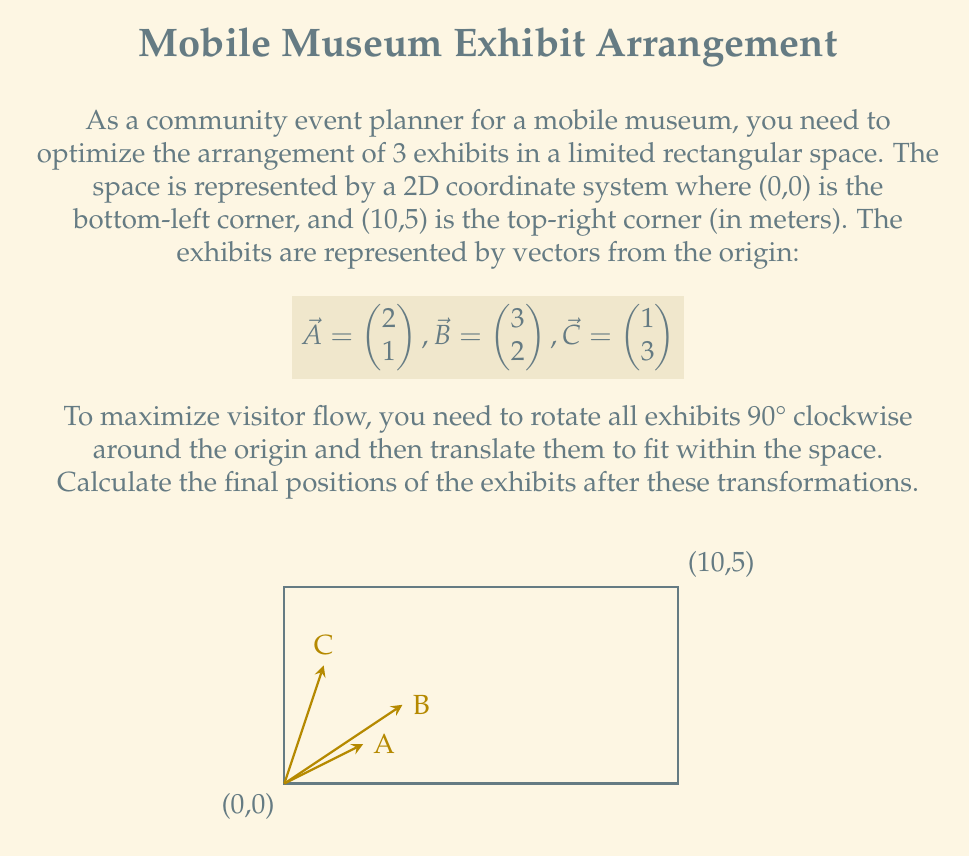Help me with this question. Let's approach this step-by-step:

1) First, we need to rotate all vectors 90° clockwise. The rotation matrix for a 90° clockwise rotation is:

   $$R = \begin{pmatrix} 0 & 1 \\ -1 & 0 \end{pmatrix}$$

2) We apply this rotation to each vector:

   For $\vec{A}$: 
   $$R\vec{A} = \begin{pmatrix} 0 & 1 \\ -1 & 0 \end{pmatrix} \begin{pmatrix} 2 \\ 1 \end{pmatrix} = \begin{pmatrix} 1 \\ -2 \end{pmatrix}$$

   For $\vec{B}$:
   $$R\vec{B} = \begin{pmatrix} 0 & 1 \\ -1 & 0 \end{pmatrix} \begin{pmatrix} 3 \\ 2 \end{pmatrix} = \begin{pmatrix} 2 \\ -3 \end{pmatrix}$$

   For $\vec{C}$:
   $$R\vec{C} = \begin{pmatrix} 0 & 1 \\ -1 & 0 \end{pmatrix} \begin{pmatrix} 1 \\ 3 \end{pmatrix} = \begin{pmatrix} 3 \\ -1 \end{pmatrix}$$

3) Now, we need to translate these rotated vectors to fit within the space. To do this, we need to move all points up by 3 units (to make all y-coordinates non-negative) and right by 7 units (to fit within the 10m width).

4) The translation vector is thus $\vec{T} = \begin{pmatrix} 7 \\ 3 \end{pmatrix}$.

5) We add this translation vector to each rotated vector:

   For $\vec{A}$: $\begin{pmatrix} 1 \\ -2 \end{pmatrix} + \begin{pmatrix} 7 \\ 3 \end{pmatrix} = \begin{pmatrix} 8 \\ 1 \end{pmatrix}$

   For $\vec{B}$: $\begin{pmatrix} 2 \\ -3 \end{pmatrix} + \begin{pmatrix} 7 \\ 3 \end{pmatrix} = \begin{pmatrix} 9 \\ 0 \end{pmatrix}$

   For $\vec{C}$: $\begin{pmatrix} 3 \\ -1 \end{pmatrix} + \begin{pmatrix} 7 \\ 3 \end{pmatrix} = \begin{pmatrix} 10 \\ 2 \end{pmatrix}$

These are the final positions of the exhibits after rotation and translation.
Answer: $A(8,1)$, $B(9,0)$, $C(10,2)$ 